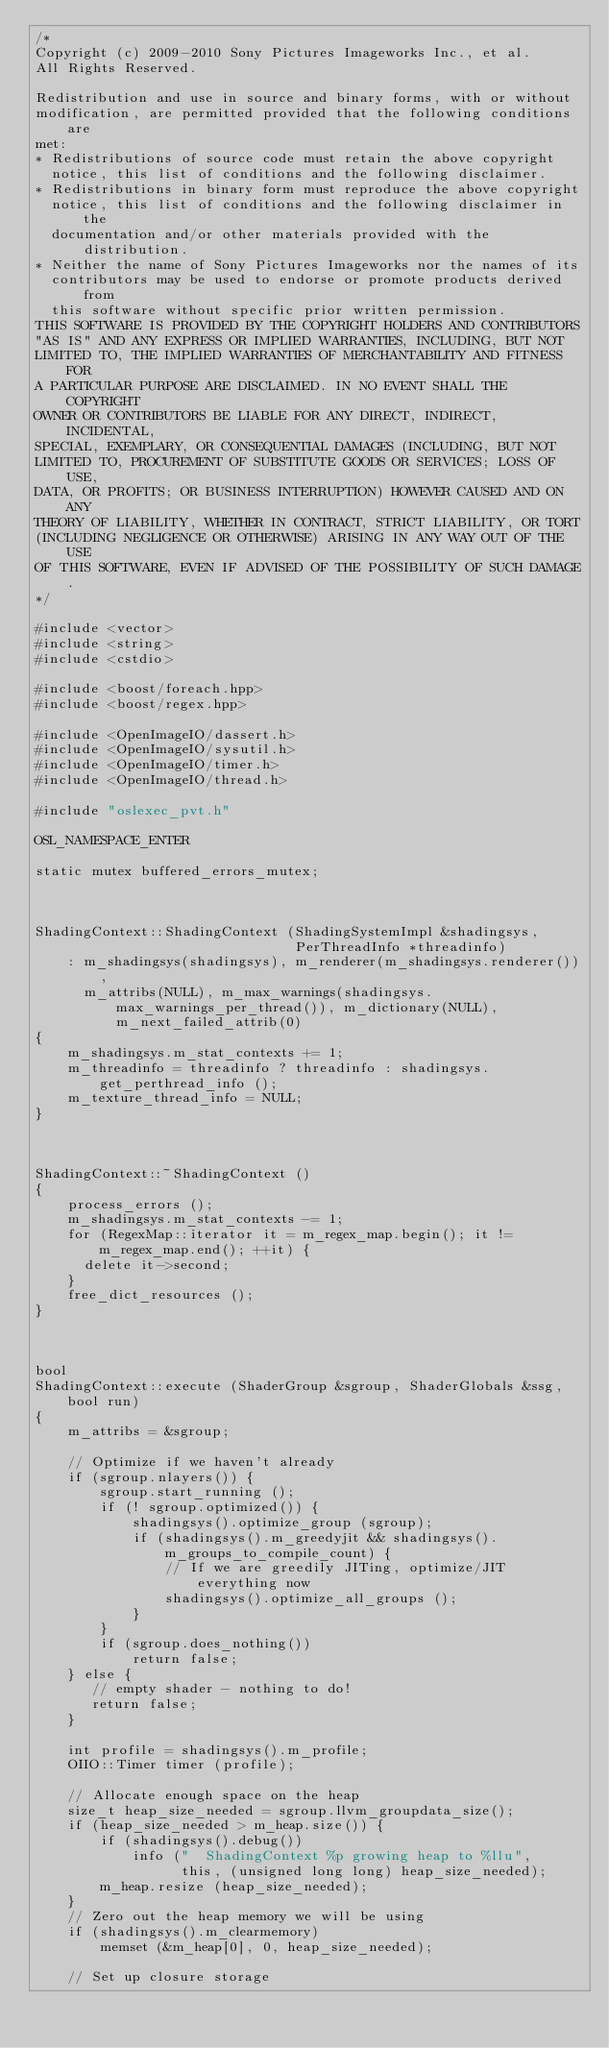<code> <loc_0><loc_0><loc_500><loc_500><_C++_>/*
Copyright (c) 2009-2010 Sony Pictures Imageworks Inc., et al.
All Rights Reserved.

Redistribution and use in source and binary forms, with or without
modification, are permitted provided that the following conditions are
met:
* Redistributions of source code must retain the above copyright
  notice, this list of conditions and the following disclaimer.
* Redistributions in binary form must reproduce the above copyright
  notice, this list of conditions and the following disclaimer in the
  documentation and/or other materials provided with the distribution.
* Neither the name of Sony Pictures Imageworks nor the names of its
  contributors may be used to endorse or promote products derived from
  this software without specific prior written permission.
THIS SOFTWARE IS PROVIDED BY THE COPYRIGHT HOLDERS AND CONTRIBUTORS
"AS IS" AND ANY EXPRESS OR IMPLIED WARRANTIES, INCLUDING, BUT NOT
LIMITED TO, THE IMPLIED WARRANTIES OF MERCHANTABILITY AND FITNESS FOR
A PARTICULAR PURPOSE ARE DISCLAIMED. IN NO EVENT SHALL THE COPYRIGHT
OWNER OR CONTRIBUTORS BE LIABLE FOR ANY DIRECT, INDIRECT, INCIDENTAL,
SPECIAL, EXEMPLARY, OR CONSEQUENTIAL DAMAGES (INCLUDING, BUT NOT
LIMITED TO, PROCUREMENT OF SUBSTITUTE GOODS OR SERVICES; LOSS OF USE,
DATA, OR PROFITS; OR BUSINESS INTERRUPTION) HOWEVER CAUSED AND ON ANY
THEORY OF LIABILITY, WHETHER IN CONTRACT, STRICT LIABILITY, OR TORT
(INCLUDING NEGLIGENCE OR OTHERWISE) ARISING IN ANY WAY OUT OF THE USE
OF THIS SOFTWARE, EVEN IF ADVISED OF THE POSSIBILITY OF SUCH DAMAGE.
*/

#include <vector>
#include <string>
#include <cstdio>

#include <boost/foreach.hpp>
#include <boost/regex.hpp>

#include <OpenImageIO/dassert.h>
#include <OpenImageIO/sysutil.h>
#include <OpenImageIO/timer.h>
#include <OpenImageIO/thread.h>

#include "oslexec_pvt.h"

OSL_NAMESPACE_ENTER

static mutex buffered_errors_mutex;



ShadingContext::ShadingContext (ShadingSystemImpl &shadingsys,
                                PerThreadInfo *threadinfo)
    : m_shadingsys(shadingsys), m_renderer(m_shadingsys.renderer()),
      m_attribs(NULL), m_max_warnings(shadingsys.max_warnings_per_thread()), m_dictionary(NULL), m_next_failed_attrib(0)
{
    m_shadingsys.m_stat_contexts += 1;
    m_threadinfo = threadinfo ? threadinfo : shadingsys.get_perthread_info ();
    m_texture_thread_info = NULL;
}



ShadingContext::~ShadingContext ()
{
    process_errors ();
    m_shadingsys.m_stat_contexts -= 1;
    for (RegexMap::iterator it = m_regex_map.begin(); it != m_regex_map.end(); ++it) {
      delete it->second;
    }
    free_dict_resources ();
}



bool
ShadingContext::execute (ShaderGroup &sgroup, ShaderGlobals &ssg, bool run)
{
    m_attribs = &sgroup;

    // Optimize if we haven't already
    if (sgroup.nlayers()) {
        sgroup.start_running ();
        if (! sgroup.optimized()) {
            shadingsys().optimize_group (sgroup);
            if (shadingsys().m_greedyjit && shadingsys().m_groups_to_compile_count) {
                // If we are greedily JITing, optimize/JIT everything now
                shadingsys().optimize_all_groups ();
            }
        }
        if (sgroup.does_nothing())
            return false;
    } else {
       // empty shader - nothing to do!
       return false;
    }

    int profile = shadingsys().m_profile;
    OIIO::Timer timer (profile);

    // Allocate enough space on the heap
    size_t heap_size_needed = sgroup.llvm_groupdata_size();
    if (heap_size_needed > m_heap.size()) {
        if (shadingsys().debug())
            info ("  ShadingContext %p growing heap to %llu",
                  this, (unsigned long long) heap_size_needed);
        m_heap.resize (heap_size_needed);
    }
    // Zero out the heap memory we will be using
    if (shadingsys().m_clearmemory)
        memset (&m_heap[0], 0, heap_size_needed);

    // Set up closure storage</code> 